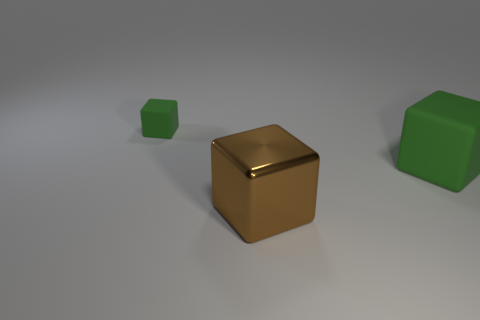There is a thing that is both left of the large green thing and right of the tiny matte block; what is its color?
Provide a succinct answer. Brown. What is the large brown object made of?
Offer a very short reply. Metal. The green thing that is on the right side of the brown shiny thing has what shape?
Provide a short and direct response. Cube. There is a matte object that is the same size as the brown block; what color is it?
Your answer should be very brief. Green. Do the block that is right of the big brown metallic thing and the small green cube have the same material?
Ensure brevity in your answer.  Yes. There is a block that is both to the right of the small rubber cube and left of the large green matte block; what is its size?
Keep it short and to the point. Large. How big is the object to the right of the large brown thing?
Offer a terse response. Large. What shape is the thing that is the same color as the big rubber cube?
Provide a succinct answer. Cube. What is the shape of the green object that is on the left side of the matte thing right of the green cube that is on the left side of the big metal thing?
Your answer should be compact. Cube. What number of other objects are the same shape as the large rubber thing?
Offer a terse response. 2. 